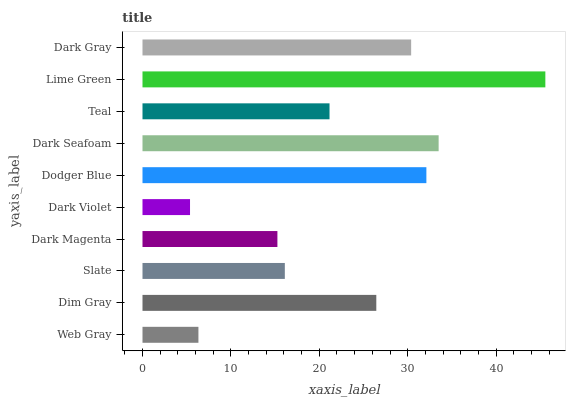Is Dark Violet the minimum?
Answer yes or no. Yes. Is Lime Green the maximum?
Answer yes or no. Yes. Is Dim Gray the minimum?
Answer yes or no. No. Is Dim Gray the maximum?
Answer yes or no. No. Is Dim Gray greater than Web Gray?
Answer yes or no. Yes. Is Web Gray less than Dim Gray?
Answer yes or no. Yes. Is Web Gray greater than Dim Gray?
Answer yes or no. No. Is Dim Gray less than Web Gray?
Answer yes or no. No. Is Dim Gray the high median?
Answer yes or no. Yes. Is Teal the low median?
Answer yes or no. Yes. Is Teal the high median?
Answer yes or no. No. Is Dark Seafoam the low median?
Answer yes or no. No. 